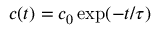Convert formula to latex. <formula><loc_0><loc_0><loc_500><loc_500>c ( t ) = c _ { 0 } \exp ( - t / \tau )</formula> 